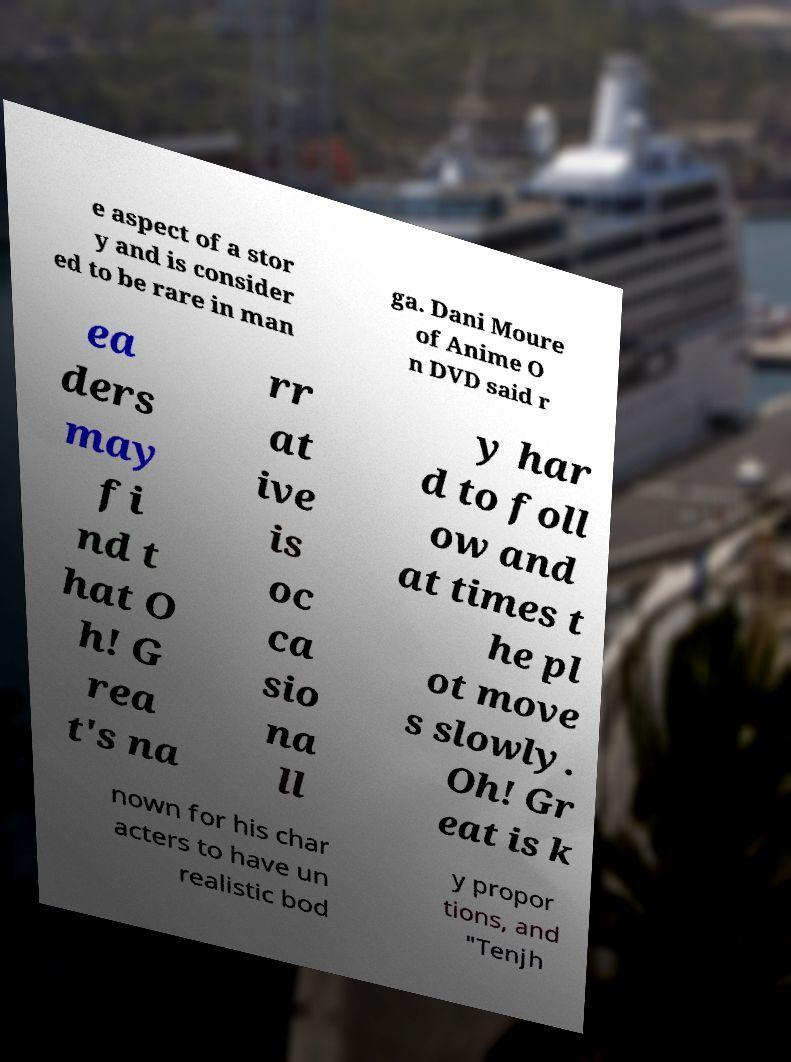There's text embedded in this image that I need extracted. Can you transcribe it verbatim? e aspect of a stor y and is consider ed to be rare in man ga. Dani Moure of Anime O n DVD said r ea ders may fi nd t hat O h! G rea t's na rr at ive is oc ca sio na ll y har d to foll ow and at times t he pl ot move s slowly. Oh! Gr eat is k nown for his char acters to have un realistic bod y propor tions, and "Tenjh 